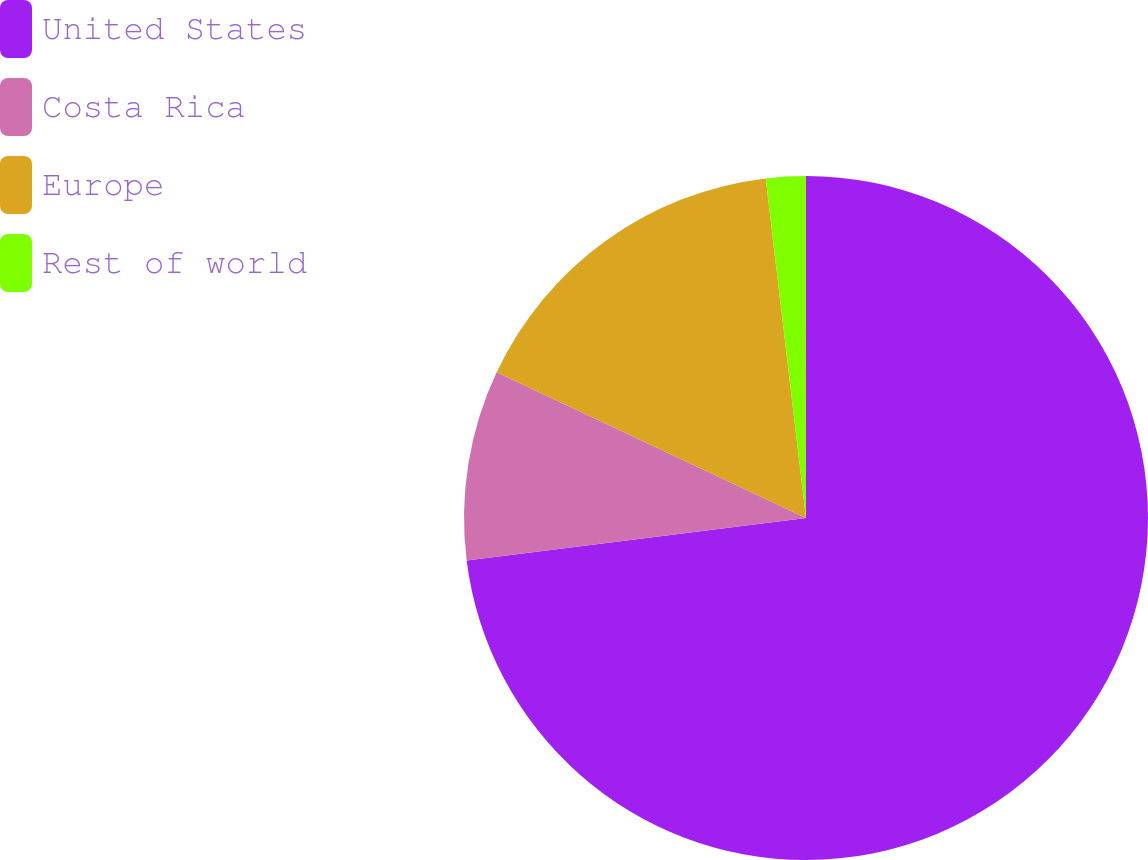Convert chart. <chart><loc_0><loc_0><loc_500><loc_500><pie_chart><fcel>United States<fcel>Costa Rica<fcel>Europe<fcel>Rest of world<nl><fcel>73.02%<fcel>8.99%<fcel>16.11%<fcel>1.88%<nl></chart> 